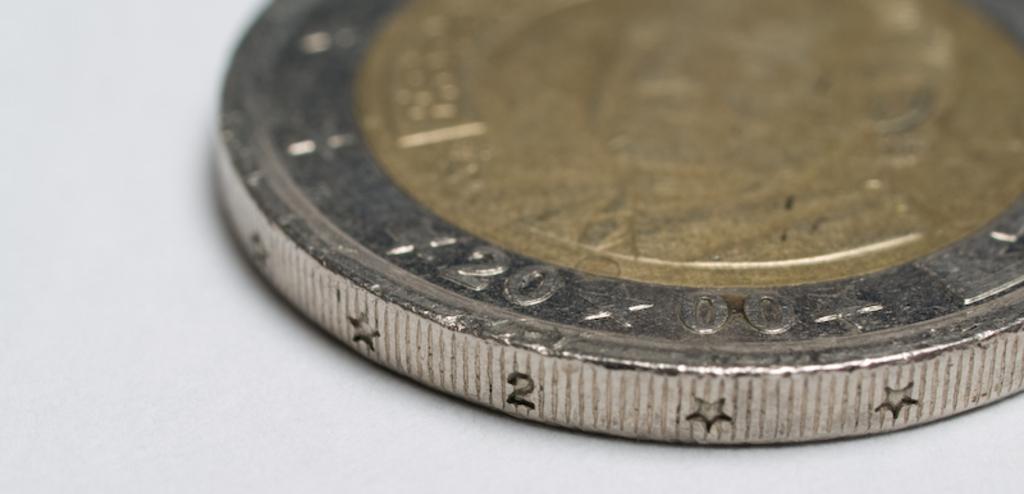What number is on the side of the coin?
Provide a short and direct response. 2. What are the numbers on the top of the coin?
Your answer should be very brief. 20 00. 